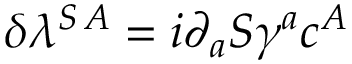<formula> <loc_0><loc_0><loc_500><loc_500>\delta \lambda ^ { S \, A } = i \partial _ { a } S \gamma ^ { a } c ^ { A }</formula> 